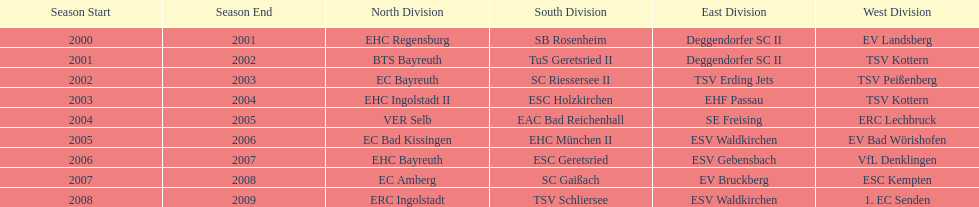What was the first club for the north in the 2000's? EHC Regensburg. 